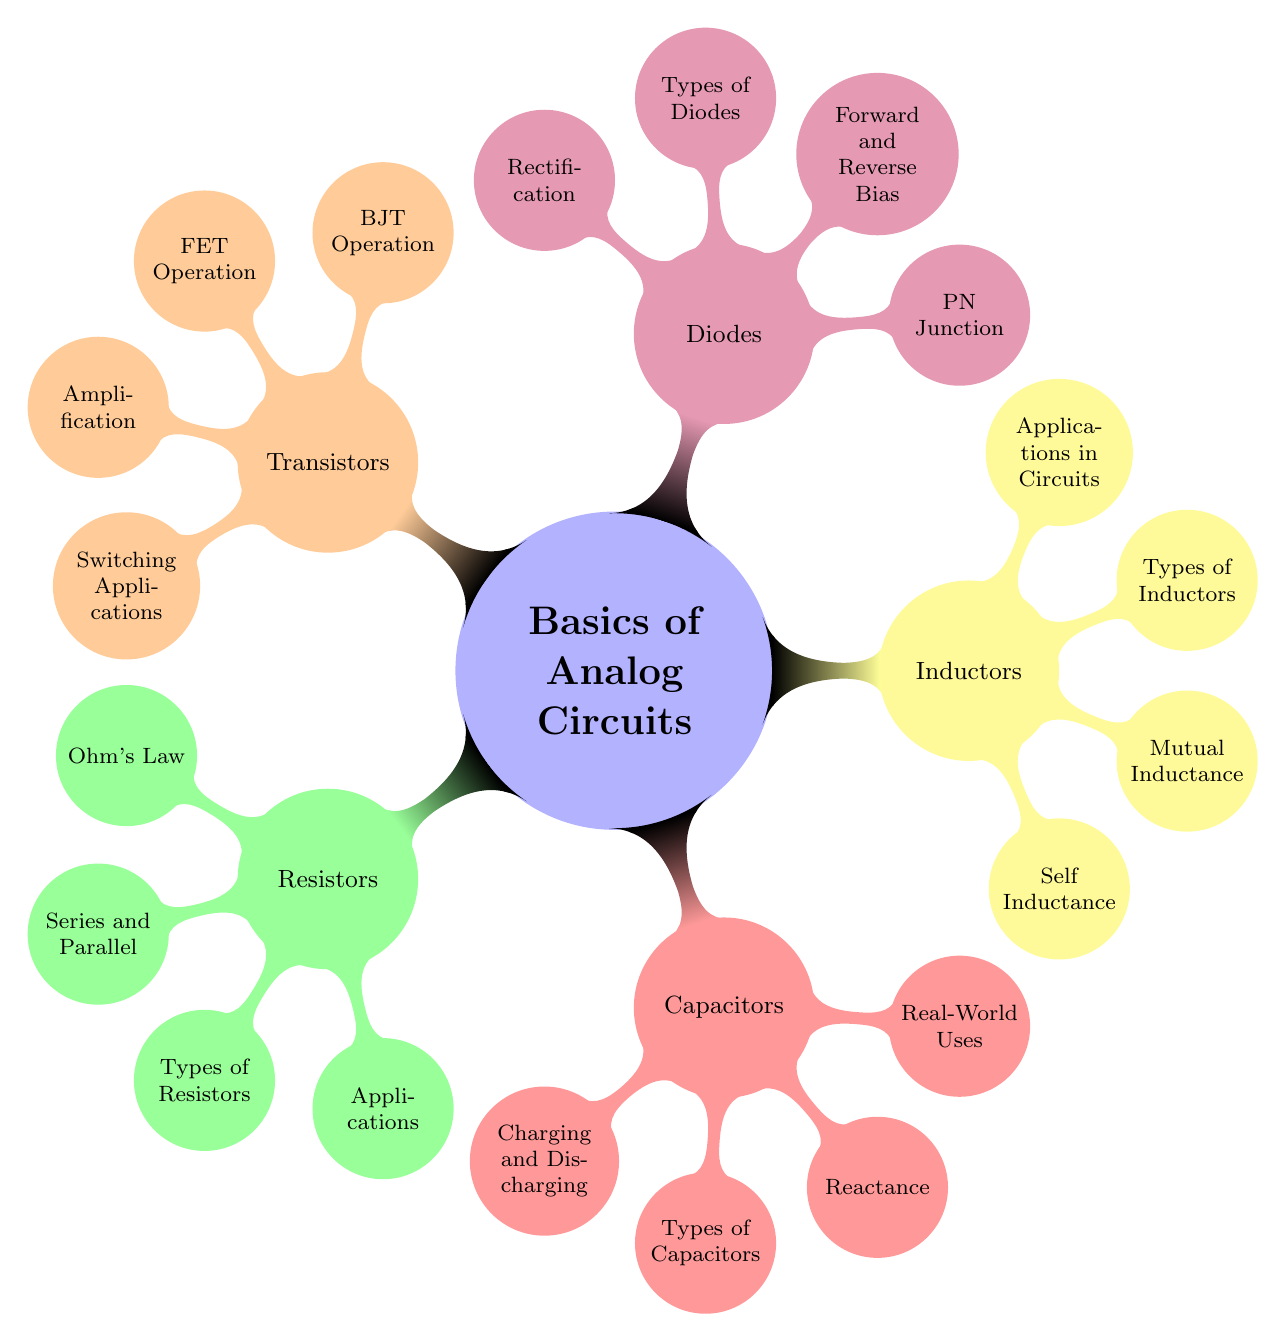What is the main topic of the mind map? The main topic is labeled at the center of the diagram and is clearly stated as "Basics of Analog Circuits."
Answer: Basics of Analog Circuits How many main branches are there under the main topic? There are five main branches extending from the central topic, representing five primary categories: Resistors, Capacitors, Inductors, Diodes, and Transistors.
Answer: 5 Which component category includes the concept of "Self Inductance"? By tracing the branches, "Self Inductance" is a subnode that belongs to the main branch labeled "Inductors."
Answer: Inductors What are the two types of bias discussed in the "Diodes" section? Looking at the subnodes under "Diodes," the words "Forward and Reverse Bias" are explicitly mentioned, indicating the two types of bias discussed in this category.
Answer: Forward and Reverse Bias Which components are involved in the amplification process according to the diagram? The diagram indicates that the subnode "Amplification" is listed under the main branch of "Transistors," showing that transistors are the components involved in this process.
Answer: Transistors How many types of capacitors are listed in the capacitors section? Under the "Capacitors" node, one of the subnodes is "Types of Capacitors," which suggests there are various types, but the exact number is not specified in the diagram. However, since there are multiple subnodes, we count this as one general category.
Answer: 1 Which two concepts are compared under the section titled "Inductors"? The "Inductors" branch has subnodes that include "Self Inductance" and "Mutual Inductance," indicating these two concepts are compared within that category.
Answer: Self Inductance and Mutual Inductance What is the primary application of diodes as indicated in the mind map? The diagram shows that "Rectification" is a subnode under the "Diodes" section, indicating that rectification is a primary application of diodes.
Answer: Rectification How are capacitors charged and discharged according to the mind map? The mind map includes the concept "Charging and Discharging" as a subnode under "Capacitors," indicating that these processes are discussed within this category.
Answer: Charging and Discharging 